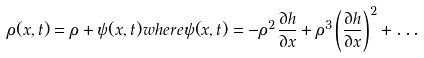Convert formula to latex. <formula><loc_0><loc_0><loc_500><loc_500>\rho ( x , t ) = \rho + \psi ( x , t ) w h e r e \psi ( x , t ) = - \rho ^ { 2 } \frac { \partial h } { \partial x } + \rho ^ { 3 } \left ( \frac { \partial h } { \partial x } \right ) ^ { 2 } + \dots</formula> 